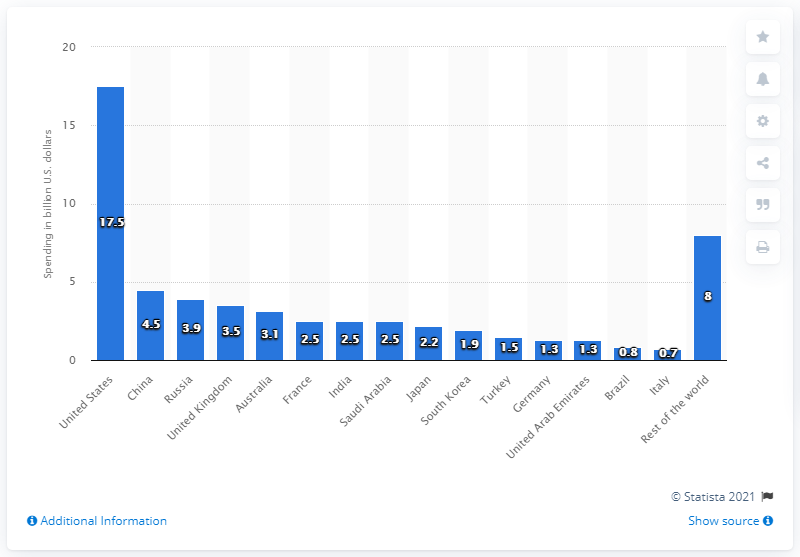Identify some key points in this picture. The United States is expected to spend an estimated 17.5 billion dollars on drones between the years 2017 and 2021. 